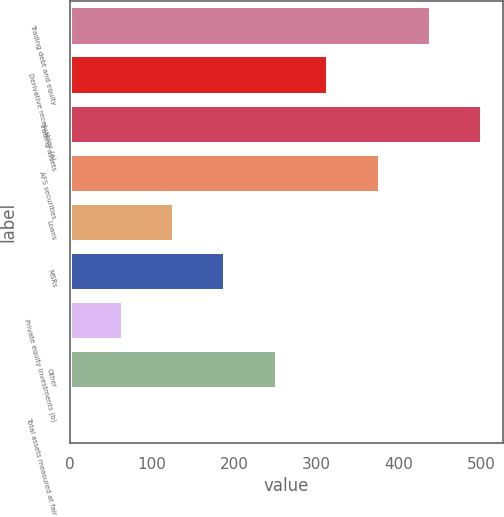Convert chart. <chart><loc_0><loc_0><loc_500><loc_500><bar_chart><fcel>Trading debt and equity<fcel>Derivative receivables (a)<fcel>Trading assets<fcel>AFS securities<fcel>Loans<fcel>MSRs<fcel>Private equity investments (b)<fcel>Other<fcel>Total assets measured at fair<nl><fcel>439.2<fcel>314.2<fcel>501.7<fcel>376.7<fcel>126.7<fcel>189.2<fcel>64.2<fcel>251.7<fcel>1.7<nl></chart> 